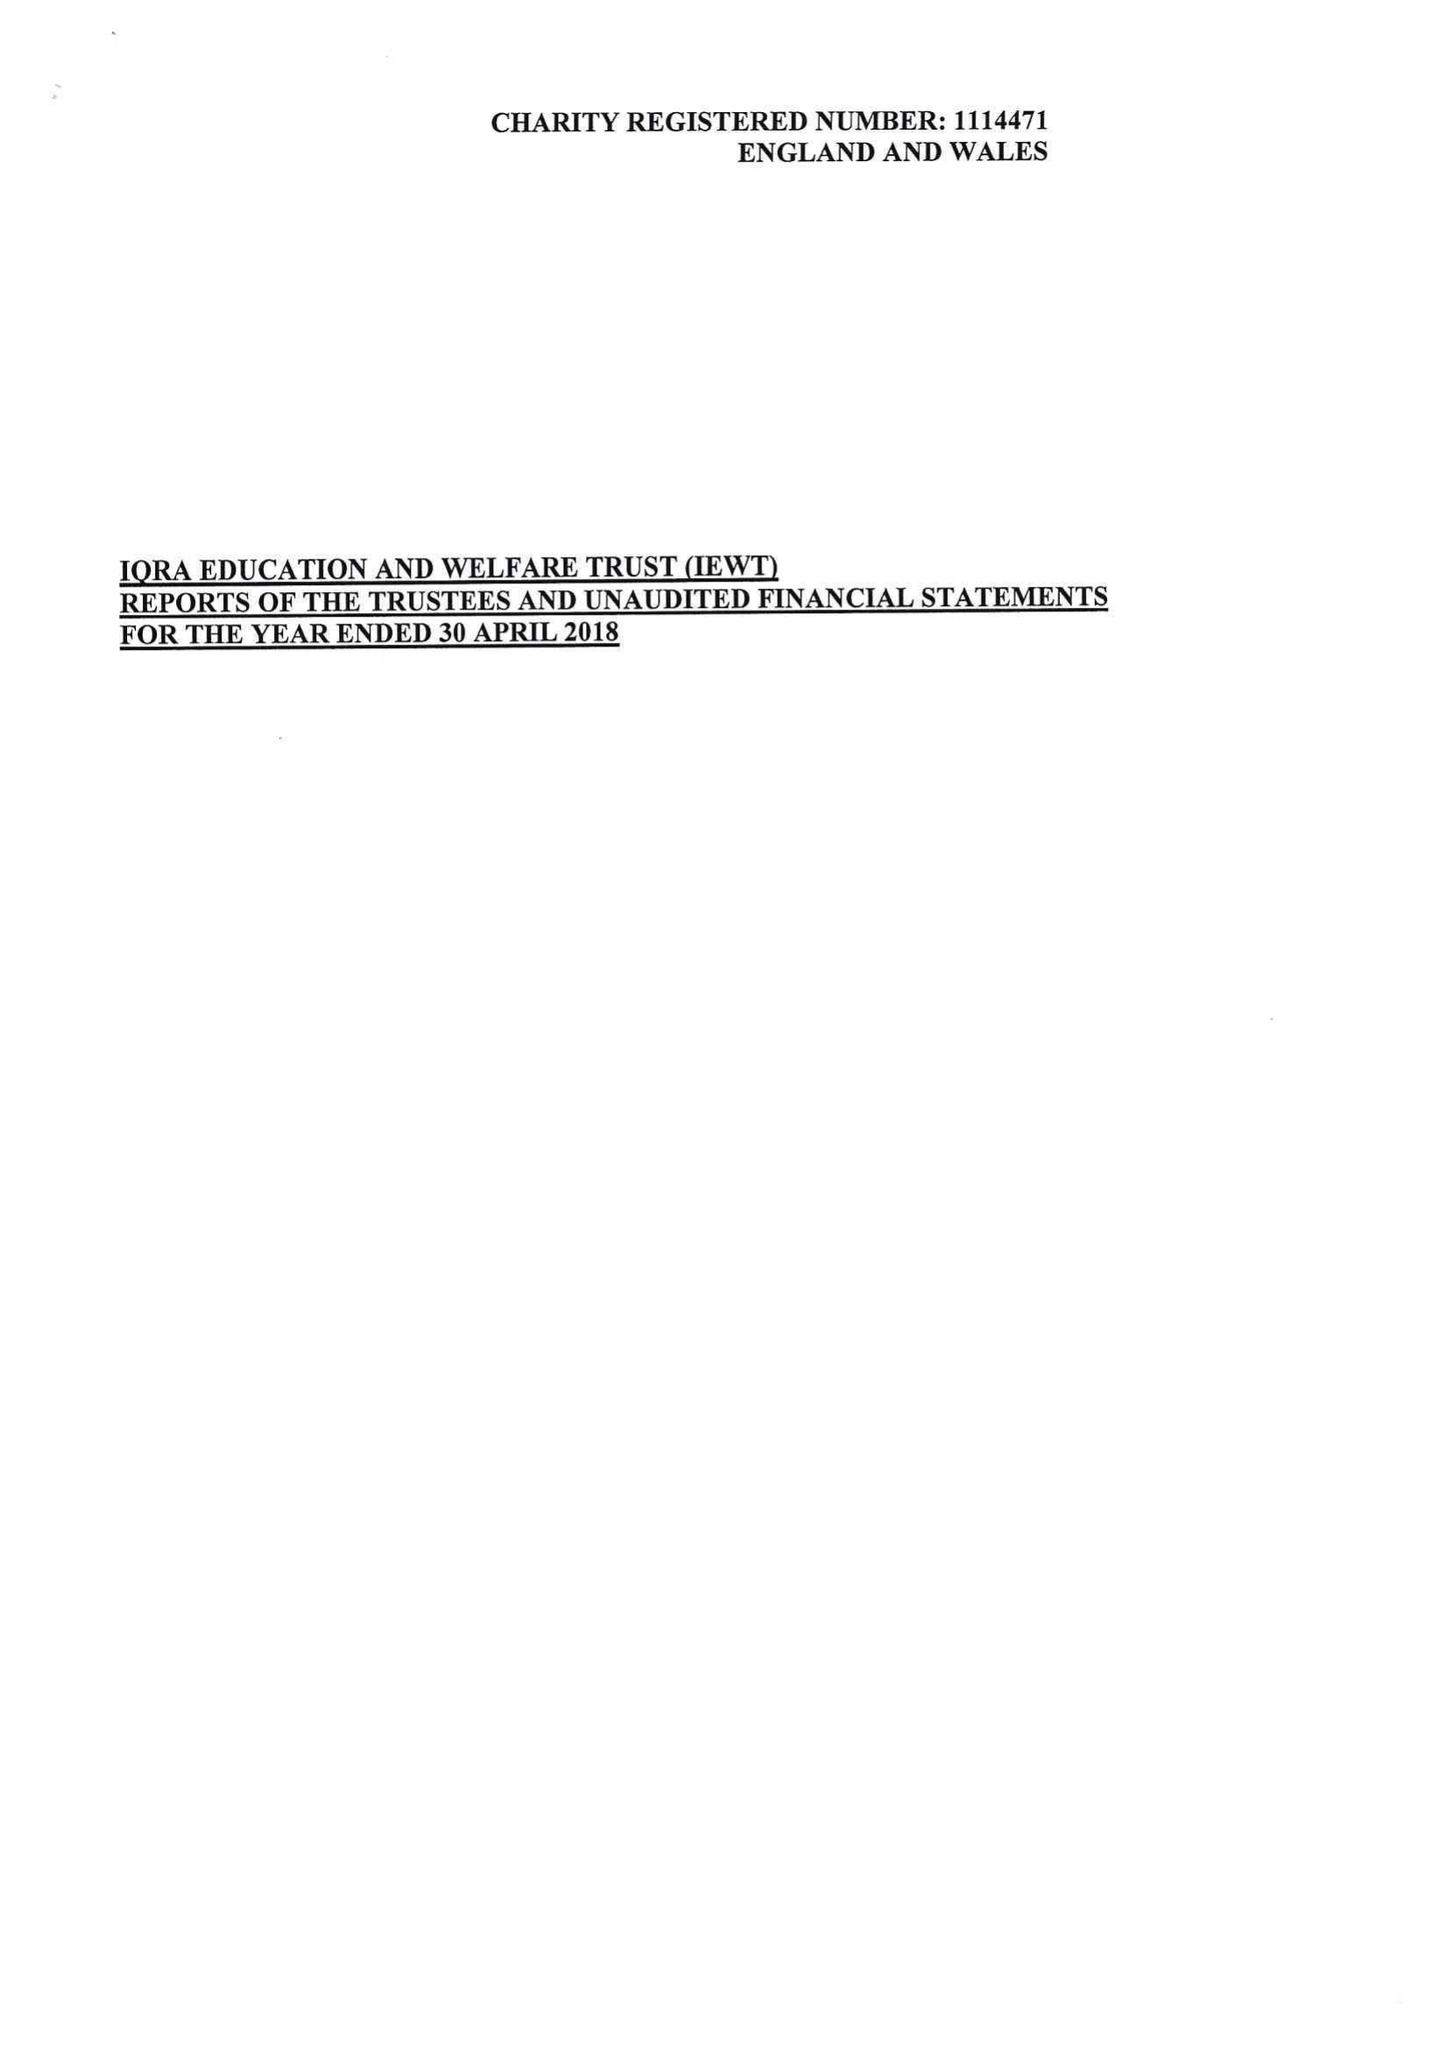What is the value for the charity_number?
Answer the question using a single word or phrase. 1114471 